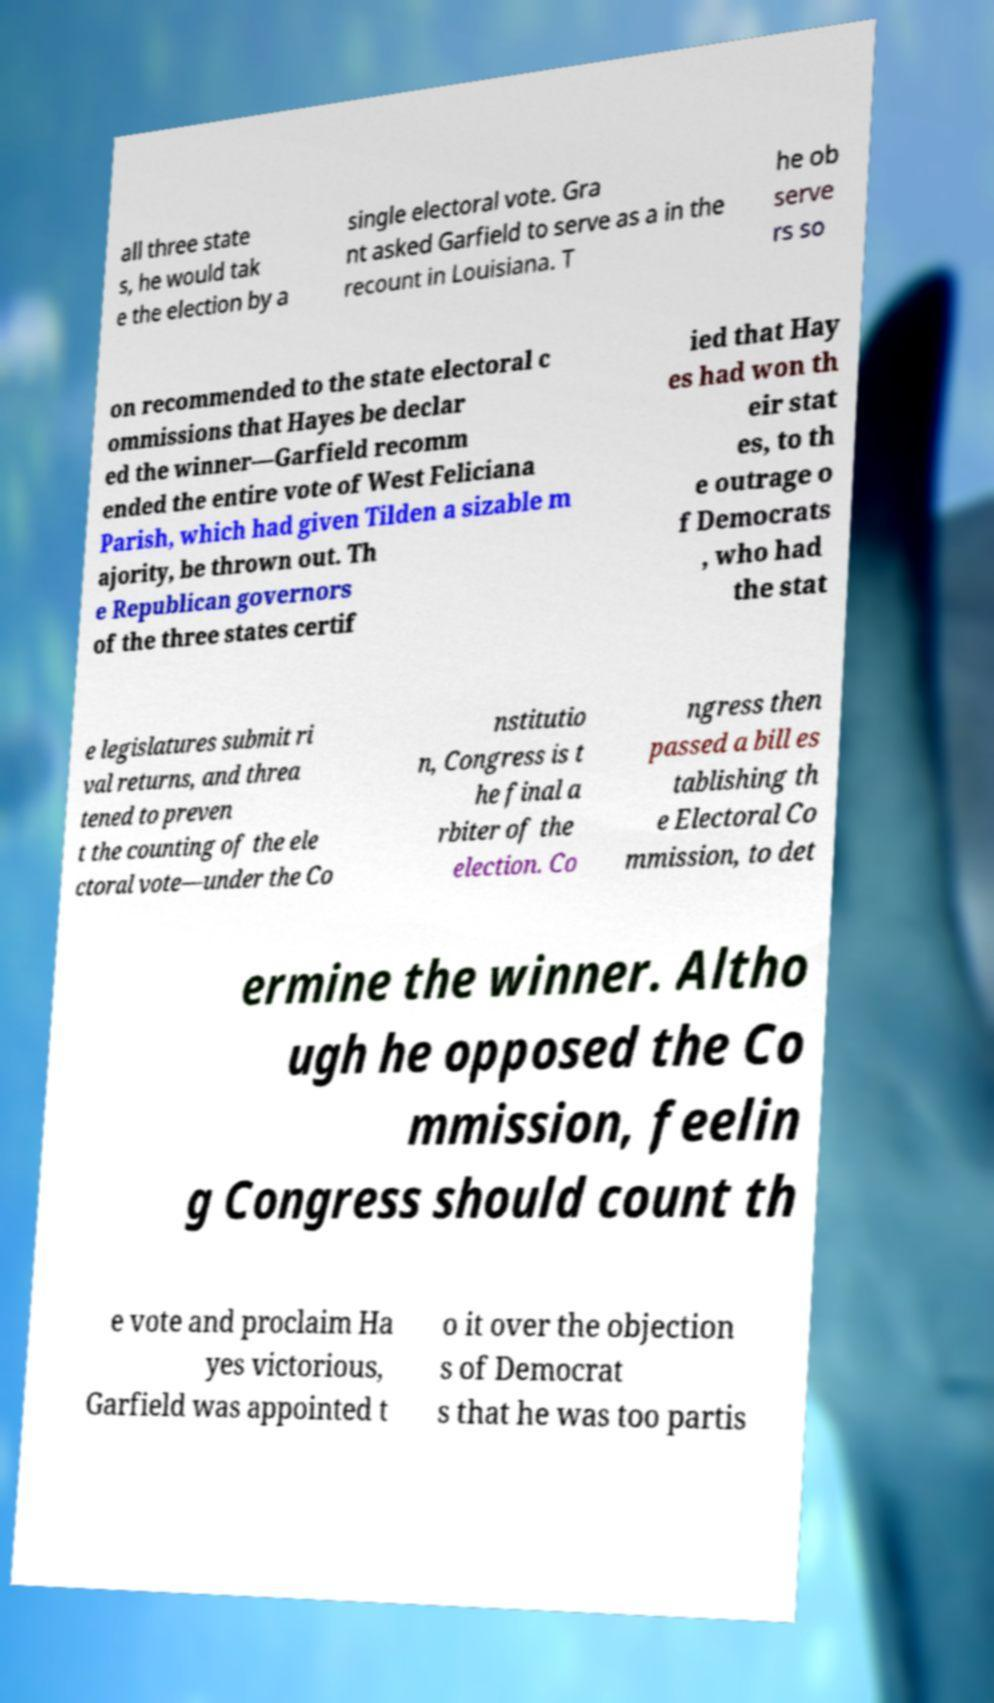Please identify and transcribe the text found in this image. all three state s, he would tak e the election by a single electoral vote. Gra nt asked Garfield to serve as a in the recount in Louisiana. T he ob serve rs so on recommended to the state electoral c ommissions that Hayes be declar ed the winner—Garfield recomm ended the entire vote of West Feliciana Parish, which had given Tilden a sizable m ajority, be thrown out. Th e Republican governors of the three states certif ied that Hay es had won th eir stat es, to th e outrage o f Democrats , who had the stat e legislatures submit ri val returns, and threa tened to preven t the counting of the ele ctoral vote—under the Co nstitutio n, Congress is t he final a rbiter of the election. Co ngress then passed a bill es tablishing th e Electoral Co mmission, to det ermine the winner. Altho ugh he opposed the Co mmission, feelin g Congress should count th e vote and proclaim Ha yes victorious, Garfield was appointed t o it over the objection s of Democrat s that he was too partis 